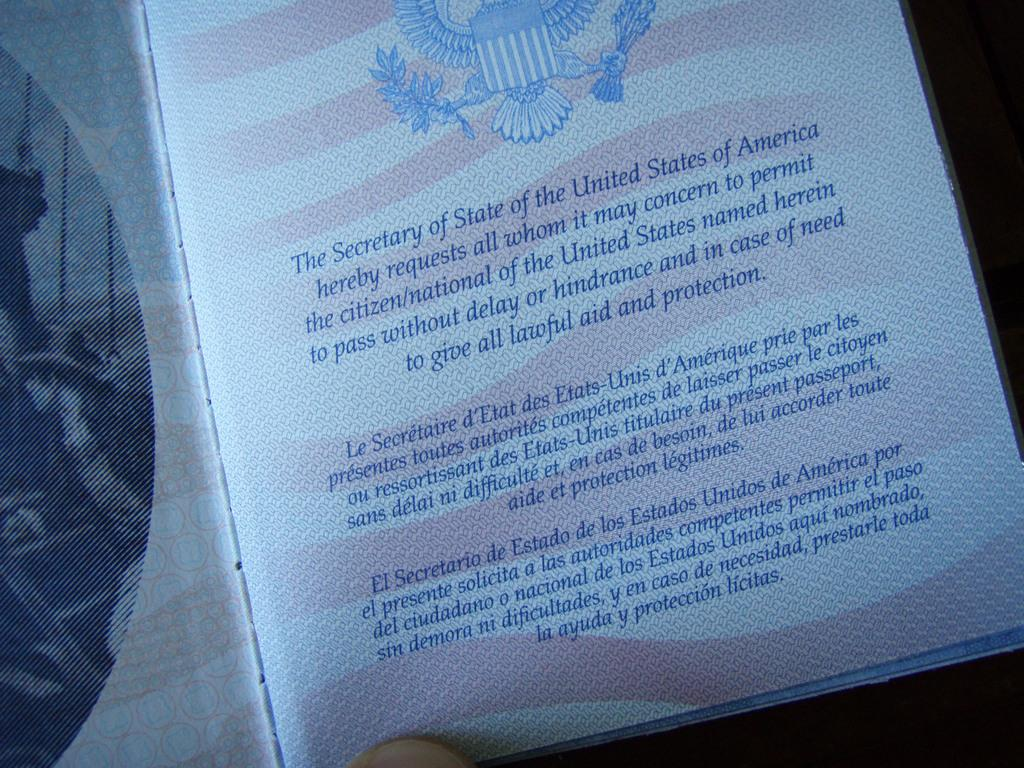<image>
Describe the image concisely. Inside the passport is a page with information from The Secretary of State of the United States. 